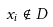Convert formula to latex. <formula><loc_0><loc_0><loc_500><loc_500>x _ { i } \notin D</formula> 